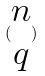<formula> <loc_0><loc_0><loc_500><loc_500>( \begin{matrix} n \\ q \end{matrix} )</formula> 